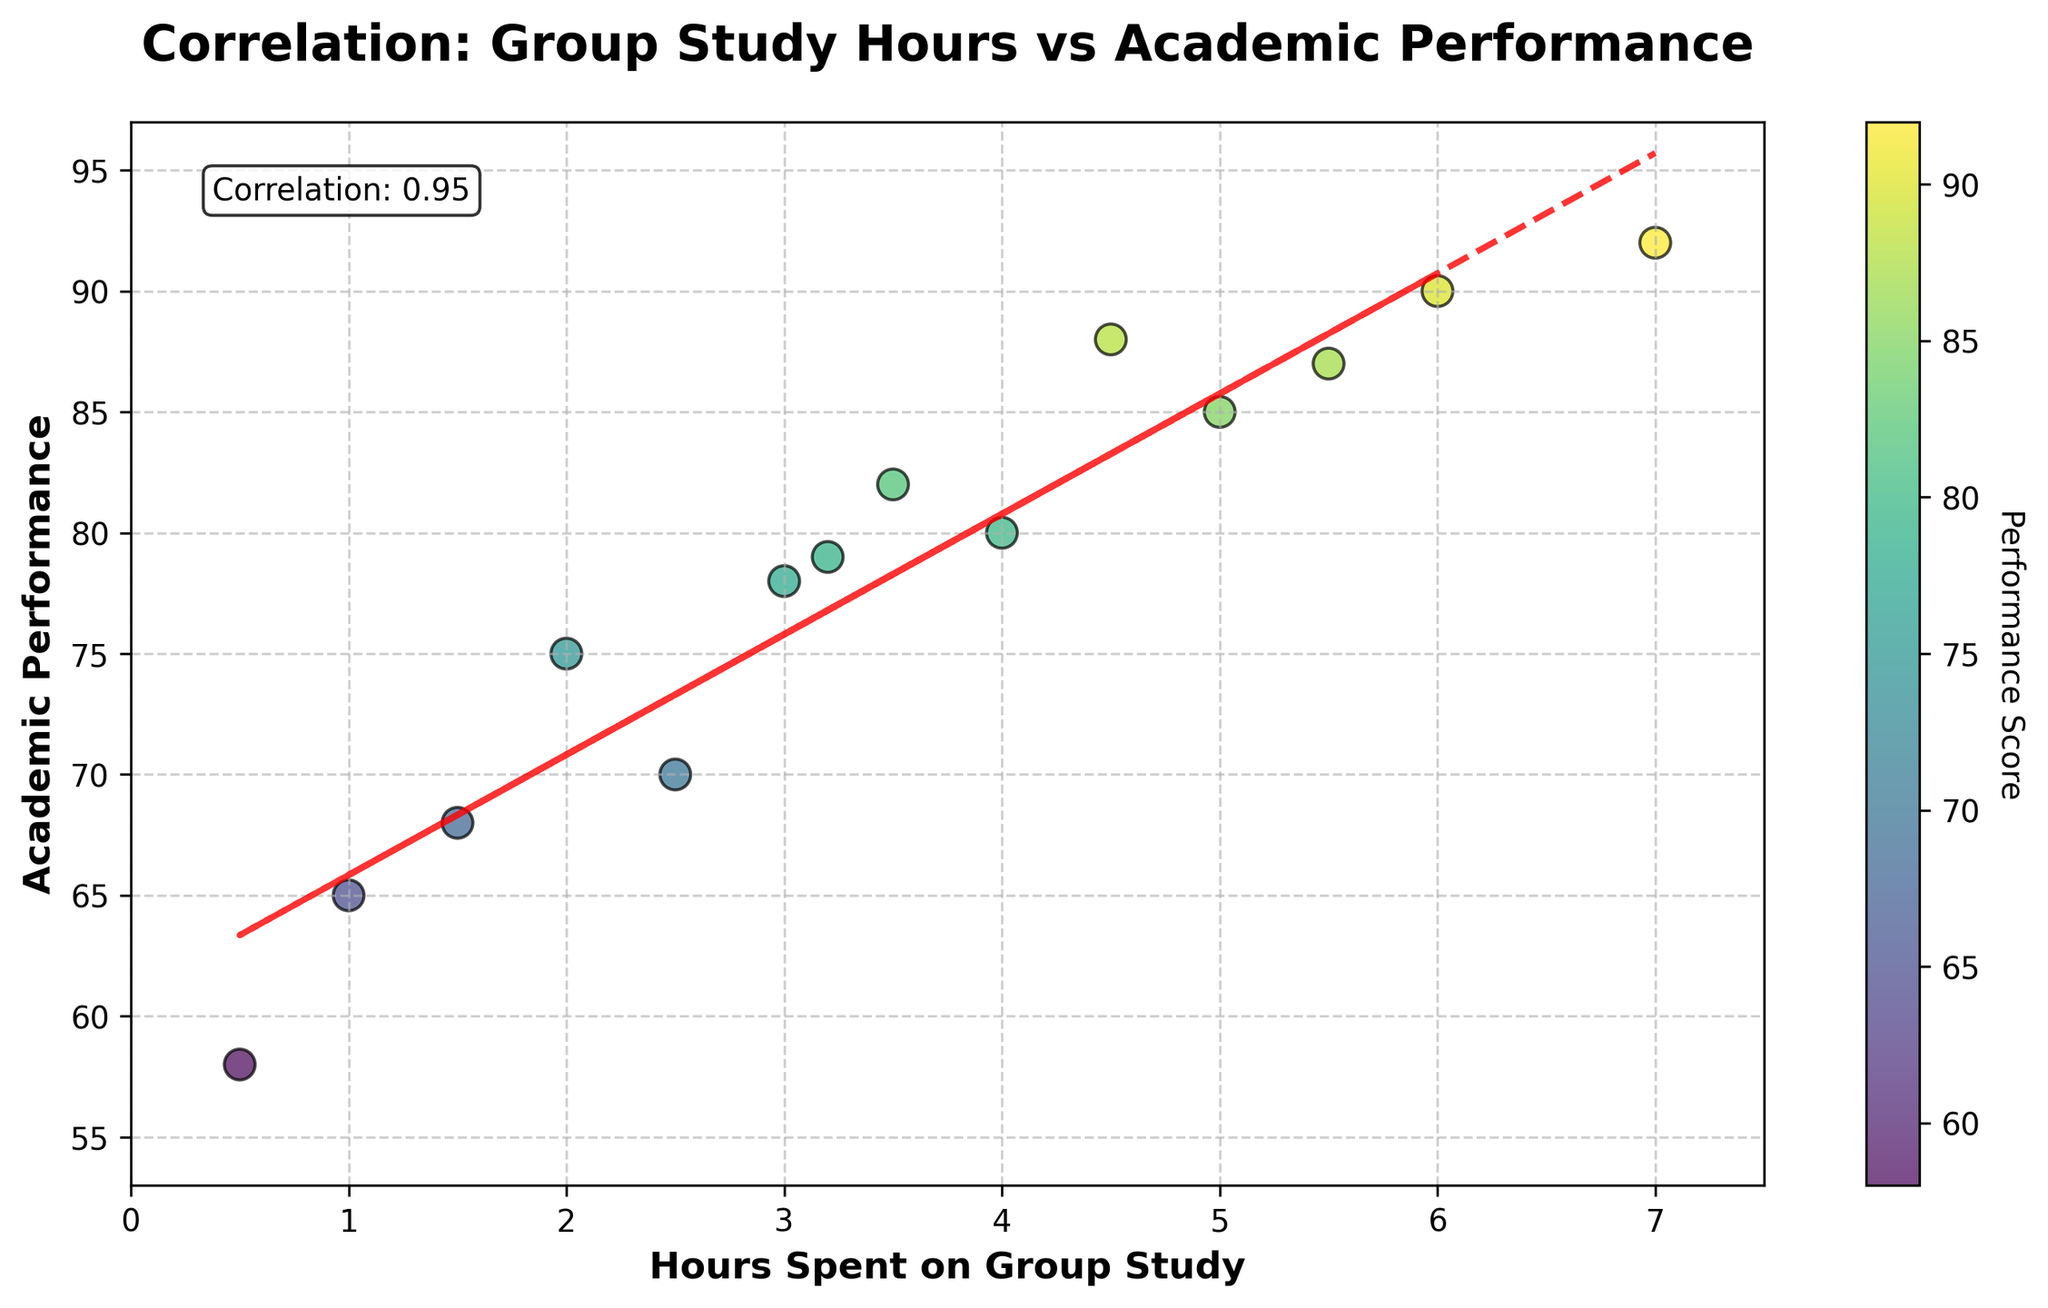How many data points are there on the plot? To find the number of data points, count the number of scatter plot points visible in the figure.
Answer: 13 What is the title of the plot? This information is directly visible at the top of the plot.
Answer: Correlation: Group Study Hours vs Academic Performance What is the range of values on the x-axis? Check the x-axis from the lowest value to the highest value, which is labeled from 0 to around 7.5.
Answer: 0 to 7.5 How would you describe the trend line? Observe the red dashed line on the plot. It shows a positive slope, indicating that as the hours spent on group study increase, academic performance also tends to increase.
Answer: Positively sloped What is the correlation coefficient shown on the plot? Look for the text annotation on the plot, usually located within the plot area, that indicates the correlation value.
Answer: 0.84 Which data point has the lowest academic performance, and what are its hours spent on group study? Identify the data point at the lowest position on the y-axis. Its x-coordinate represents the hours spent on group study.
Answer: Hours: 0.5, Performance: 58 What is the academic performance of students who spent 4 hours on group study? Find the data point where the x-coordinate is 4 and note its corresponding y-coordinate.
Answer: 80 How does the performance score change approximately per hour of group study according to the trend line? Calculate the slope of the trend line. Use the polyfit/polynomial fit coefficients to understand how academic performance changes per hour of group study. The formula for slope can be derived from the red dashed line.
Answer: Approximately 5.7 points per hour Compare the academic performance of students who spent 2 hours and 4 hours on group study. Which group performed better and by how much? Identify the performance scores for 2 and 4 hours. Subtract the score of the 2-hour group from the 4-hour group to find the difference.
Answer: The group at 4 hours performed 5 points better What is the average academic performance of students who spent between 2 and 5 hours on group study? Find the data points between the x-values of 2 and 5, then calculate their average y-values.
Answer: (75 + 70 + 78 + 80 + 82) / 5 = 77 